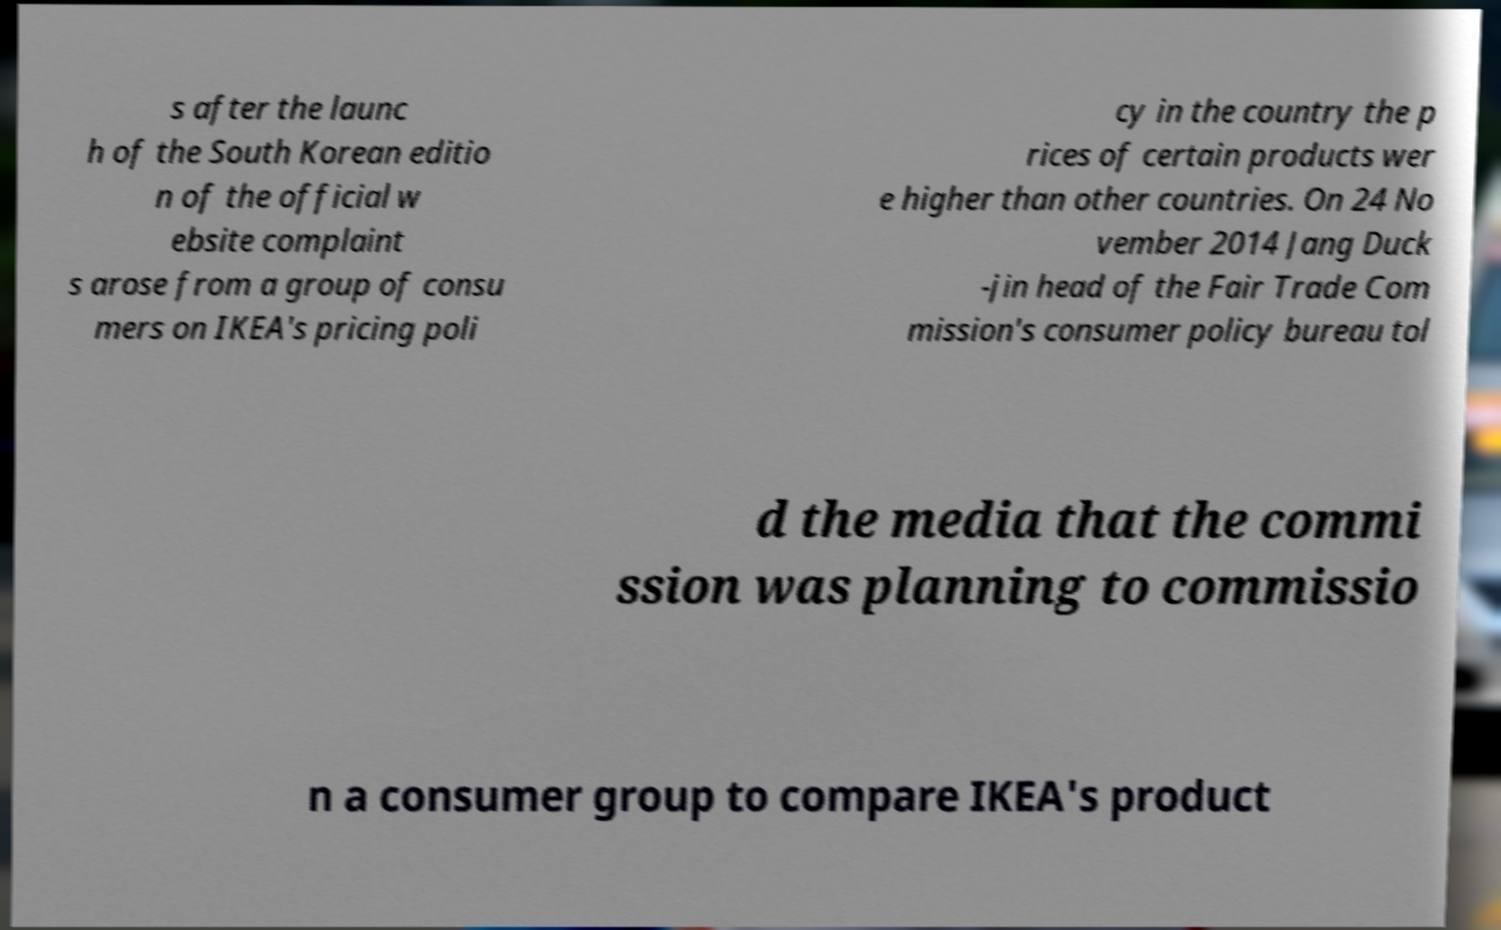Could you assist in decoding the text presented in this image and type it out clearly? s after the launc h of the South Korean editio n of the official w ebsite complaint s arose from a group of consu mers on IKEA's pricing poli cy in the country the p rices of certain products wer e higher than other countries. On 24 No vember 2014 Jang Duck -jin head of the Fair Trade Com mission's consumer policy bureau tol d the media that the commi ssion was planning to commissio n a consumer group to compare IKEA's product 